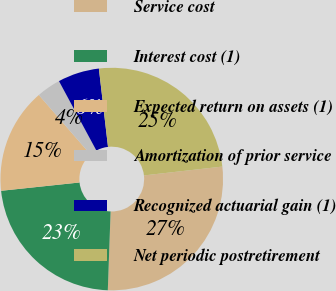Convert chart to OTSL. <chart><loc_0><loc_0><loc_500><loc_500><pie_chart><fcel>Service cost<fcel>Interest cost (1)<fcel>Expected return on assets (1)<fcel>Amortization of prior service<fcel>Recognized actuarial gain (1)<fcel>Net periodic postretirement<nl><fcel>27.35%<fcel>22.75%<fcel>15.31%<fcel>3.5%<fcel>6.02%<fcel>25.05%<nl></chart> 